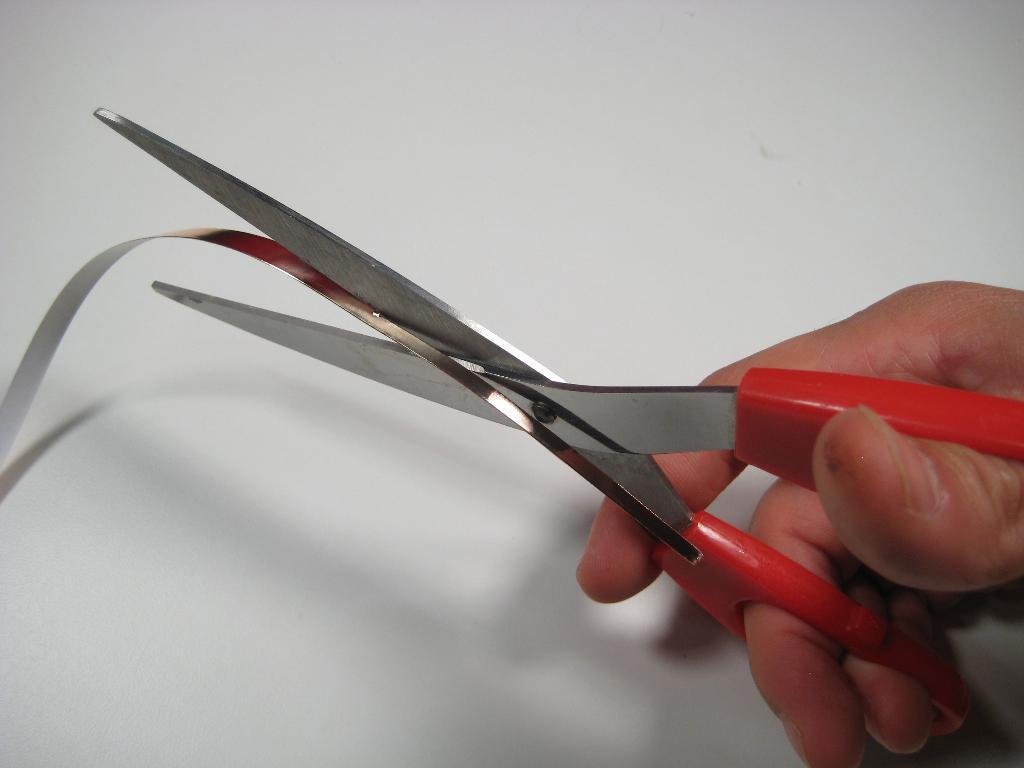Please provide a concise description of this image. In this we can see a person's hand holding a scissor and cutting a metal strip. 